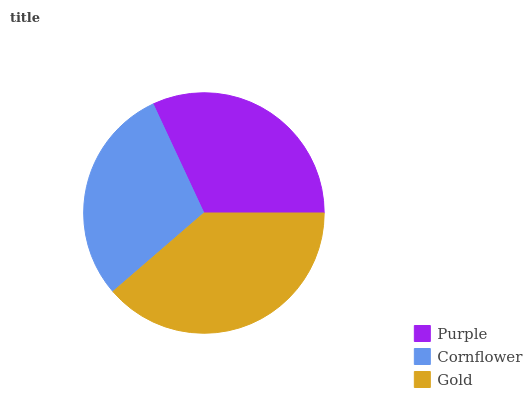Is Cornflower the minimum?
Answer yes or no. Yes. Is Gold the maximum?
Answer yes or no. Yes. Is Gold the minimum?
Answer yes or no. No. Is Cornflower the maximum?
Answer yes or no. No. Is Gold greater than Cornflower?
Answer yes or no. Yes. Is Cornflower less than Gold?
Answer yes or no. Yes. Is Cornflower greater than Gold?
Answer yes or no. No. Is Gold less than Cornflower?
Answer yes or no. No. Is Purple the high median?
Answer yes or no. Yes. Is Purple the low median?
Answer yes or no. Yes. Is Cornflower the high median?
Answer yes or no. No. Is Gold the low median?
Answer yes or no. No. 